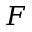Convert formula to latex. <formula><loc_0><loc_0><loc_500><loc_500>F</formula> 